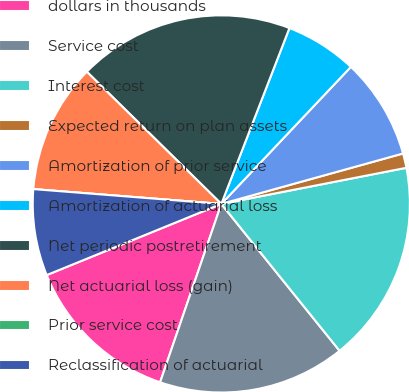Convert chart to OTSL. <chart><loc_0><loc_0><loc_500><loc_500><pie_chart><fcel>dollars in thousands<fcel>Service cost<fcel>Interest cost<fcel>Expected return on plan assets<fcel>Amortization of prior service<fcel>Amortization of actuarial loss<fcel>Net periodic postretirement<fcel>Net actuarial loss (gain)<fcel>Prior service cost<fcel>Reclassification of actuarial<nl><fcel>13.58%<fcel>16.05%<fcel>17.28%<fcel>1.24%<fcel>8.64%<fcel>6.17%<fcel>18.52%<fcel>11.11%<fcel>0.0%<fcel>7.41%<nl></chart> 